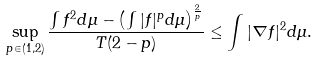<formula> <loc_0><loc_0><loc_500><loc_500>\sup _ { p \in ( 1 , 2 ) } \frac { \int f ^ { 2 } d \mu - \left ( \int | f | ^ { p } d \mu \right ) ^ { \frac { 2 } { p } } } { T ( 2 - p ) } \leq \int | \nabla f | ^ { 2 } d \mu .</formula> 